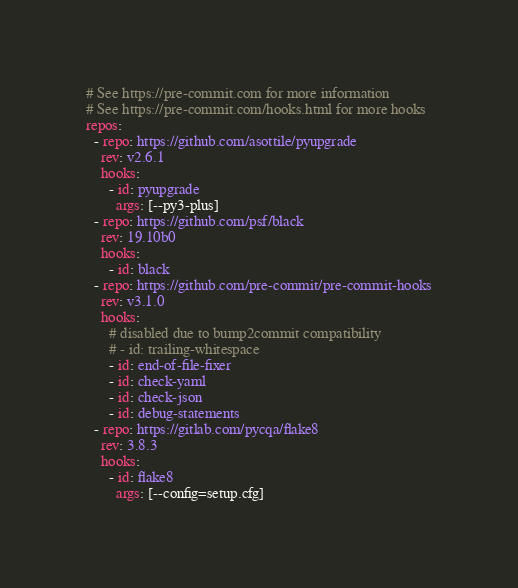Convert code to text. <code><loc_0><loc_0><loc_500><loc_500><_YAML_># See https://pre-commit.com for more information
# See https://pre-commit.com/hooks.html for more hooks
repos:
  - repo: https://github.com/asottile/pyupgrade
    rev: v2.6.1
    hooks:
      - id: pyupgrade
        args: [--py3-plus]
  - repo: https://github.com/psf/black
    rev: 19.10b0
    hooks:
      - id: black
  - repo: https://github.com/pre-commit/pre-commit-hooks
    rev: v3.1.0
    hooks:
      # disabled due to bump2commit compatibility
      # - id: trailing-whitespace
      - id: end-of-file-fixer
      - id: check-yaml
      - id: check-json
      - id: debug-statements
  - repo: https://gitlab.com/pycqa/flake8
    rev: 3.8.3
    hooks:
      - id: flake8
        args: [--config=setup.cfg]
</code> 